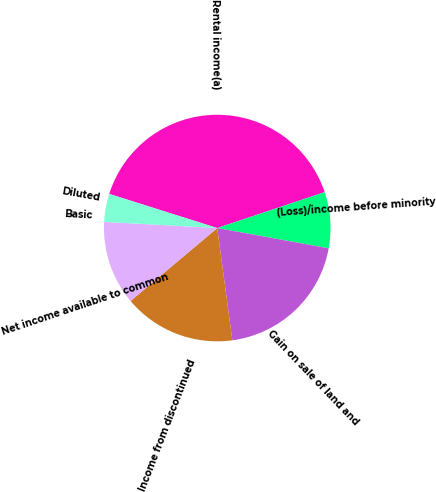<chart> <loc_0><loc_0><loc_500><loc_500><pie_chart><fcel>Rental income(a)<fcel>(Loss)/income before minority<fcel>Gain on sale of land and<fcel>Income from discontinued<fcel>Net income available to common<fcel>Basic<fcel>Diluted<nl><fcel>40.0%<fcel>8.0%<fcel>20.0%<fcel>16.0%<fcel>12.0%<fcel>0.0%<fcel>4.0%<nl></chart> 